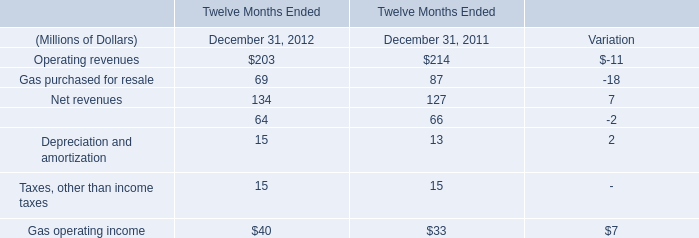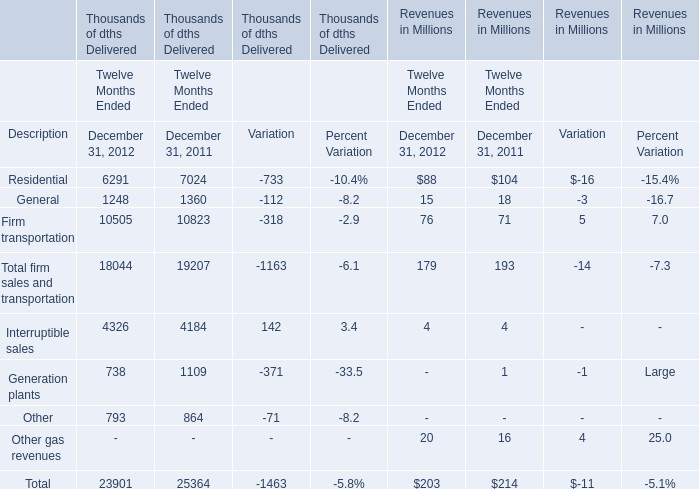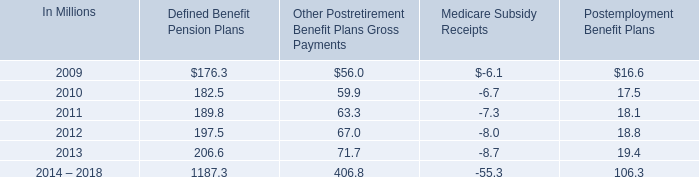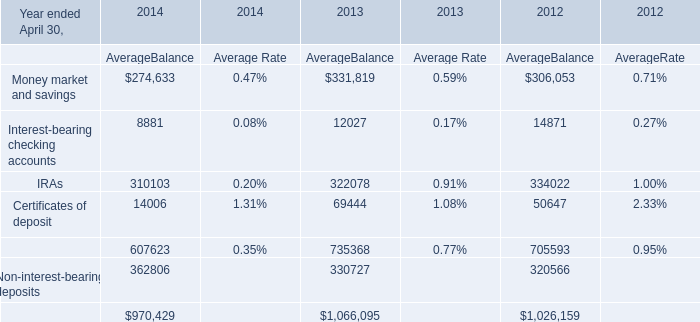What is the difference between 2012 and 2011 's highest Operating revenues? (in million) 
Answer: -11.0. what was the average total recognized expense related to defined contribution plans from 2006 to 2008 
Computations: (((61.9 + 48.3) + 45.5) / 3)
Answer: 51.9. 